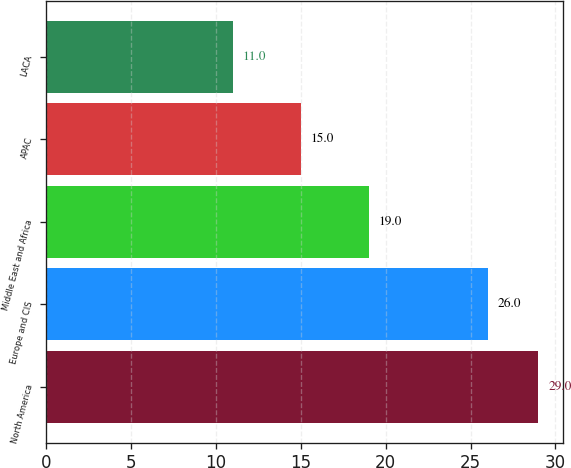Convert chart to OTSL. <chart><loc_0><loc_0><loc_500><loc_500><bar_chart><fcel>North America<fcel>Europe and CIS<fcel>Middle East and Africa<fcel>APAC<fcel>LACA<nl><fcel>29<fcel>26<fcel>19<fcel>15<fcel>11<nl></chart> 